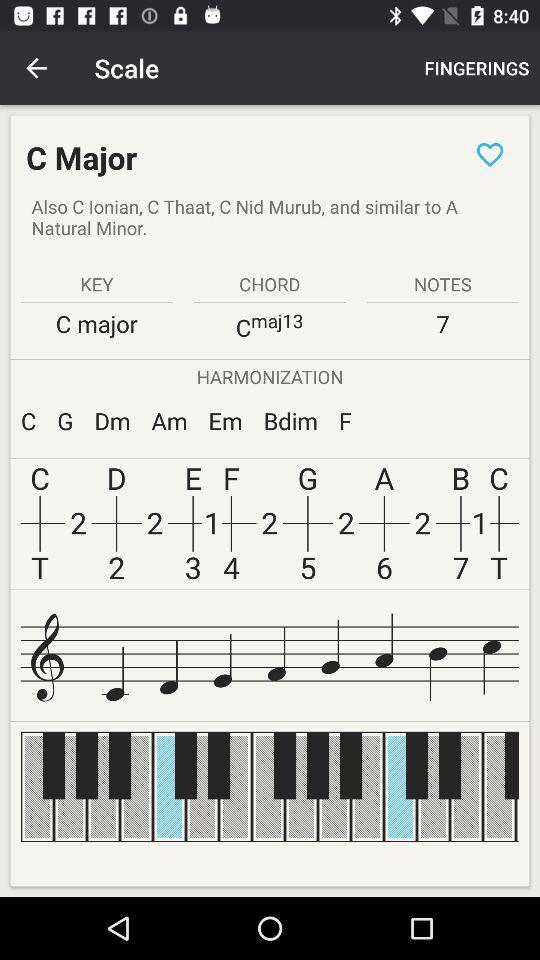What is mentioned in the "CHORD"? In "CHORD", "Cmaj13" is mentioned. 